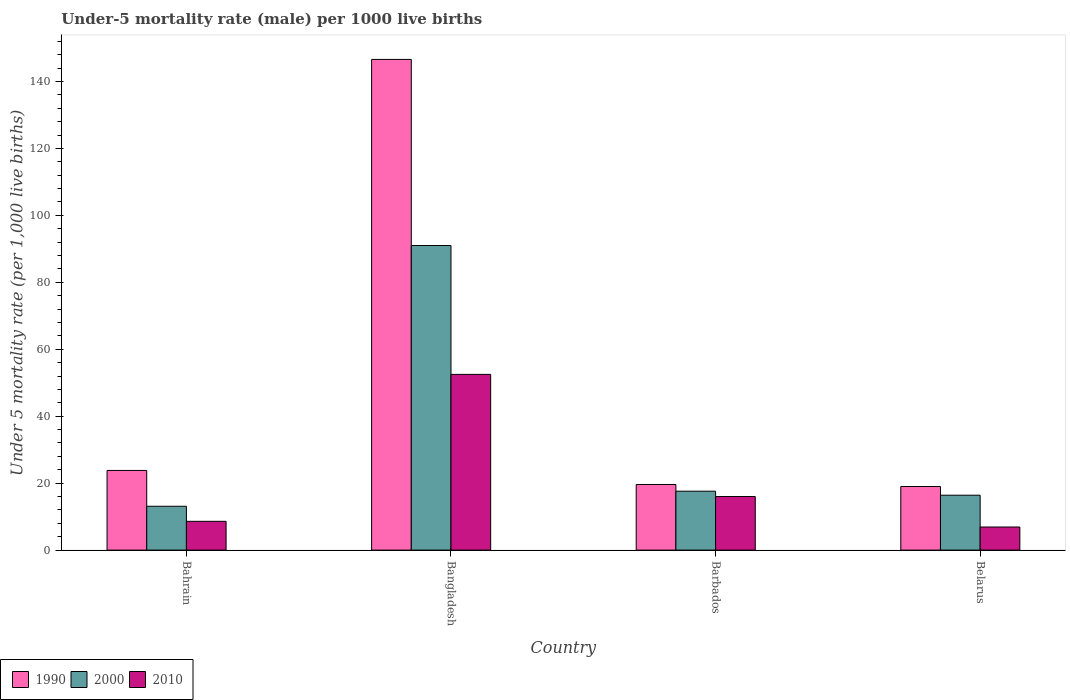How many groups of bars are there?
Keep it short and to the point. 4. Are the number of bars per tick equal to the number of legend labels?
Ensure brevity in your answer.  Yes. Are the number of bars on each tick of the X-axis equal?
Your answer should be very brief. Yes. What is the label of the 2nd group of bars from the left?
Your answer should be compact. Bangladesh. In how many cases, is the number of bars for a given country not equal to the number of legend labels?
Offer a very short reply. 0. Across all countries, what is the maximum under-five mortality rate in 2000?
Ensure brevity in your answer.  91. In which country was the under-five mortality rate in 2010 minimum?
Your answer should be very brief. Belarus. What is the total under-five mortality rate in 2010 in the graph?
Offer a terse response. 84. What is the difference between the under-five mortality rate in 2000 in Bahrain and that in Bangladesh?
Your response must be concise. -77.9. What is the difference between the under-five mortality rate in 1990 in Bahrain and the under-five mortality rate in 2000 in Barbados?
Make the answer very short. 6.2. What is the average under-five mortality rate in 2000 per country?
Make the answer very short. 34.52. What is the difference between the under-five mortality rate of/in 2010 and under-five mortality rate of/in 1990 in Bahrain?
Keep it short and to the point. -15.2. What is the ratio of the under-five mortality rate in 1990 in Bangladesh to that in Barbados?
Give a very brief answer. 7.48. Is the difference between the under-five mortality rate in 2010 in Bahrain and Barbados greater than the difference between the under-five mortality rate in 1990 in Bahrain and Barbados?
Provide a short and direct response. No. What is the difference between the highest and the lowest under-five mortality rate in 1990?
Offer a very short reply. 127.6. Is the sum of the under-five mortality rate in 2000 in Bangladesh and Belarus greater than the maximum under-five mortality rate in 2010 across all countries?
Provide a succinct answer. Yes. What does the 1st bar from the right in Belarus represents?
Your answer should be compact. 2010. How many countries are there in the graph?
Keep it short and to the point. 4. What is the difference between two consecutive major ticks on the Y-axis?
Your answer should be very brief. 20. Does the graph contain grids?
Your answer should be very brief. No. How many legend labels are there?
Offer a very short reply. 3. How are the legend labels stacked?
Give a very brief answer. Horizontal. What is the title of the graph?
Provide a succinct answer. Under-5 mortality rate (male) per 1000 live births. What is the label or title of the X-axis?
Provide a succinct answer. Country. What is the label or title of the Y-axis?
Provide a short and direct response. Under 5 mortality rate (per 1,0 live births). What is the Under 5 mortality rate (per 1,000 live births) in 1990 in Bahrain?
Offer a very short reply. 23.8. What is the Under 5 mortality rate (per 1,000 live births) in 2000 in Bahrain?
Provide a succinct answer. 13.1. What is the Under 5 mortality rate (per 1,000 live births) in 2010 in Bahrain?
Provide a short and direct response. 8.6. What is the Under 5 mortality rate (per 1,000 live births) in 1990 in Bangladesh?
Make the answer very short. 146.6. What is the Under 5 mortality rate (per 1,000 live births) in 2000 in Bangladesh?
Give a very brief answer. 91. What is the Under 5 mortality rate (per 1,000 live births) in 2010 in Bangladesh?
Your response must be concise. 52.5. What is the Under 5 mortality rate (per 1,000 live births) in 1990 in Barbados?
Your answer should be very brief. 19.6. What is the Under 5 mortality rate (per 1,000 live births) in 2000 in Belarus?
Your answer should be compact. 16.4. Across all countries, what is the maximum Under 5 mortality rate (per 1,000 live births) of 1990?
Give a very brief answer. 146.6. Across all countries, what is the maximum Under 5 mortality rate (per 1,000 live births) of 2000?
Ensure brevity in your answer.  91. Across all countries, what is the maximum Under 5 mortality rate (per 1,000 live births) in 2010?
Offer a terse response. 52.5. What is the total Under 5 mortality rate (per 1,000 live births) in 1990 in the graph?
Offer a very short reply. 209. What is the total Under 5 mortality rate (per 1,000 live births) of 2000 in the graph?
Your answer should be very brief. 138.1. What is the difference between the Under 5 mortality rate (per 1,000 live births) in 1990 in Bahrain and that in Bangladesh?
Provide a succinct answer. -122.8. What is the difference between the Under 5 mortality rate (per 1,000 live births) in 2000 in Bahrain and that in Bangladesh?
Make the answer very short. -77.9. What is the difference between the Under 5 mortality rate (per 1,000 live births) in 2010 in Bahrain and that in Bangladesh?
Provide a short and direct response. -43.9. What is the difference between the Under 5 mortality rate (per 1,000 live births) of 1990 in Bahrain and that in Barbados?
Your response must be concise. 4.2. What is the difference between the Under 5 mortality rate (per 1,000 live births) of 2000 in Bahrain and that in Barbados?
Offer a terse response. -4.5. What is the difference between the Under 5 mortality rate (per 1,000 live births) of 1990 in Bahrain and that in Belarus?
Your answer should be very brief. 4.8. What is the difference between the Under 5 mortality rate (per 1,000 live births) in 2000 in Bahrain and that in Belarus?
Offer a terse response. -3.3. What is the difference between the Under 5 mortality rate (per 1,000 live births) in 2010 in Bahrain and that in Belarus?
Offer a very short reply. 1.7. What is the difference between the Under 5 mortality rate (per 1,000 live births) of 1990 in Bangladesh and that in Barbados?
Your answer should be very brief. 127. What is the difference between the Under 5 mortality rate (per 1,000 live births) in 2000 in Bangladesh and that in Barbados?
Your answer should be compact. 73.4. What is the difference between the Under 5 mortality rate (per 1,000 live births) of 2010 in Bangladesh and that in Barbados?
Ensure brevity in your answer.  36.5. What is the difference between the Under 5 mortality rate (per 1,000 live births) of 1990 in Bangladesh and that in Belarus?
Your answer should be compact. 127.6. What is the difference between the Under 5 mortality rate (per 1,000 live births) in 2000 in Bangladesh and that in Belarus?
Keep it short and to the point. 74.6. What is the difference between the Under 5 mortality rate (per 1,000 live births) of 2010 in Bangladesh and that in Belarus?
Give a very brief answer. 45.6. What is the difference between the Under 5 mortality rate (per 1,000 live births) of 2010 in Barbados and that in Belarus?
Give a very brief answer. 9.1. What is the difference between the Under 5 mortality rate (per 1,000 live births) of 1990 in Bahrain and the Under 5 mortality rate (per 1,000 live births) of 2000 in Bangladesh?
Offer a terse response. -67.2. What is the difference between the Under 5 mortality rate (per 1,000 live births) in 1990 in Bahrain and the Under 5 mortality rate (per 1,000 live births) in 2010 in Bangladesh?
Give a very brief answer. -28.7. What is the difference between the Under 5 mortality rate (per 1,000 live births) of 2000 in Bahrain and the Under 5 mortality rate (per 1,000 live births) of 2010 in Bangladesh?
Your response must be concise. -39.4. What is the difference between the Under 5 mortality rate (per 1,000 live births) of 1990 in Bahrain and the Under 5 mortality rate (per 1,000 live births) of 2000 in Barbados?
Provide a short and direct response. 6.2. What is the difference between the Under 5 mortality rate (per 1,000 live births) of 1990 in Bahrain and the Under 5 mortality rate (per 1,000 live births) of 2000 in Belarus?
Your answer should be very brief. 7.4. What is the difference between the Under 5 mortality rate (per 1,000 live births) in 1990 in Bangladesh and the Under 5 mortality rate (per 1,000 live births) in 2000 in Barbados?
Give a very brief answer. 129. What is the difference between the Under 5 mortality rate (per 1,000 live births) in 1990 in Bangladesh and the Under 5 mortality rate (per 1,000 live births) in 2010 in Barbados?
Offer a terse response. 130.6. What is the difference between the Under 5 mortality rate (per 1,000 live births) of 1990 in Bangladesh and the Under 5 mortality rate (per 1,000 live births) of 2000 in Belarus?
Provide a succinct answer. 130.2. What is the difference between the Under 5 mortality rate (per 1,000 live births) in 1990 in Bangladesh and the Under 5 mortality rate (per 1,000 live births) in 2010 in Belarus?
Give a very brief answer. 139.7. What is the difference between the Under 5 mortality rate (per 1,000 live births) in 2000 in Bangladesh and the Under 5 mortality rate (per 1,000 live births) in 2010 in Belarus?
Your response must be concise. 84.1. What is the difference between the Under 5 mortality rate (per 1,000 live births) of 1990 in Barbados and the Under 5 mortality rate (per 1,000 live births) of 2010 in Belarus?
Offer a terse response. 12.7. What is the difference between the Under 5 mortality rate (per 1,000 live births) of 2000 in Barbados and the Under 5 mortality rate (per 1,000 live births) of 2010 in Belarus?
Ensure brevity in your answer.  10.7. What is the average Under 5 mortality rate (per 1,000 live births) in 1990 per country?
Offer a very short reply. 52.25. What is the average Under 5 mortality rate (per 1,000 live births) in 2000 per country?
Provide a succinct answer. 34.52. What is the average Under 5 mortality rate (per 1,000 live births) in 2010 per country?
Give a very brief answer. 21. What is the difference between the Under 5 mortality rate (per 1,000 live births) in 1990 and Under 5 mortality rate (per 1,000 live births) in 2000 in Bangladesh?
Provide a short and direct response. 55.6. What is the difference between the Under 5 mortality rate (per 1,000 live births) in 1990 and Under 5 mortality rate (per 1,000 live births) in 2010 in Bangladesh?
Your answer should be very brief. 94.1. What is the difference between the Under 5 mortality rate (per 1,000 live births) in 2000 and Under 5 mortality rate (per 1,000 live births) in 2010 in Bangladesh?
Your answer should be compact. 38.5. What is the difference between the Under 5 mortality rate (per 1,000 live births) of 1990 and Under 5 mortality rate (per 1,000 live births) of 2010 in Barbados?
Ensure brevity in your answer.  3.6. What is the difference between the Under 5 mortality rate (per 1,000 live births) in 2000 and Under 5 mortality rate (per 1,000 live births) in 2010 in Barbados?
Provide a succinct answer. 1.6. What is the difference between the Under 5 mortality rate (per 1,000 live births) in 1990 and Under 5 mortality rate (per 1,000 live births) in 2000 in Belarus?
Provide a succinct answer. 2.6. What is the ratio of the Under 5 mortality rate (per 1,000 live births) of 1990 in Bahrain to that in Bangladesh?
Give a very brief answer. 0.16. What is the ratio of the Under 5 mortality rate (per 1,000 live births) of 2000 in Bahrain to that in Bangladesh?
Offer a terse response. 0.14. What is the ratio of the Under 5 mortality rate (per 1,000 live births) in 2010 in Bahrain to that in Bangladesh?
Offer a terse response. 0.16. What is the ratio of the Under 5 mortality rate (per 1,000 live births) in 1990 in Bahrain to that in Barbados?
Offer a terse response. 1.21. What is the ratio of the Under 5 mortality rate (per 1,000 live births) of 2000 in Bahrain to that in Barbados?
Make the answer very short. 0.74. What is the ratio of the Under 5 mortality rate (per 1,000 live births) of 2010 in Bahrain to that in Barbados?
Give a very brief answer. 0.54. What is the ratio of the Under 5 mortality rate (per 1,000 live births) of 1990 in Bahrain to that in Belarus?
Keep it short and to the point. 1.25. What is the ratio of the Under 5 mortality rate (per 1,000 live births) in 2000 in Bahrain to that in Belarus?
Ensure brevity in your answer.  0.8. What is the ratio of the Under 5 mortality rate (per 1,000 live births) in 2010 in Bahrain to that in Belarus?
Provide a short and direct response. 1.25. What is the ratio of the Under 5 mortality rate (per 1,000 live births) of 1990 in Bangladesh to that in Barbados?
Keep it short and to the point. 7.48. What is the ratio of the Under 5 mortality rate (per 1,000 live births) of 2000 in Bangladesh to that in Barbados?
Give a very brief answer. 5.17. What is the ratio of the Under 5 mortality rate (per 1,000 live births) of 2010 in Bangladesh to that in Barbados?
Give a very brief answer. 3.28. What is the ratio of the Under 5 mortality rate (per 1,000 live births) in 1990 in Bangladesh to that in Belarus?
Your answer should be compact. 7.72. What is the ratio of the Under 5 mortality rate (per 1,000 live births) in 2000 in Bangladesh to that in Belarus?
Provide a short and direct response. 5.55. What is the ratio of the Under 5 mortality rate (per 1,000 live births) of 2010 in Bangladesh to that in Belarus?
Provide a succinct answer. 7.61. What is the ratio of the Under 5 mortality rate (per 1,000 live births) of 1990 in Barbados to that in Belarus?
Give a very brief answer. 1.03. What is the ratio of the Under 5 mortality rate (per 1,000 live births) of 2000 in Barbados to that in Belarus?
Offer a terse response. 1.07. What is the ratio of the Under 5 mortality rate (per 1,000 live births) in 2010 in Barbados to that in Belarus?
Provide a succinct answer. 2.32. What is the difference between the highest and the second highest Under 5 mortality rate (per 1,000 live births) in 1990?
Give a very brief answer. 122.8. What is the difference between the highest and the second highest Under 5 mortality rate (per 1,000 live births) in 2000?
Ensure brevity in your answer.  73.4. What is the difference between the highest and the second highest Under 5 mortality rate (per 1,000 live births) in 2010?
Your response must be concise. 36.5. What is the difference between the highest and the lowest Under 5 mortality rate (per 1,000 live births) of 1990?
Ensure brevity in your answer.  127.6. What is the difference between the highest and the lowest Under 5 mortality rate (per 1,000 live births) in 2000?
Provide a short and direct response. 77.9. What is the difference between the highest and the lowest Under 5 mortality rate (per 1,000 live births) of 2010?
Make the answer very short. 45.6. 